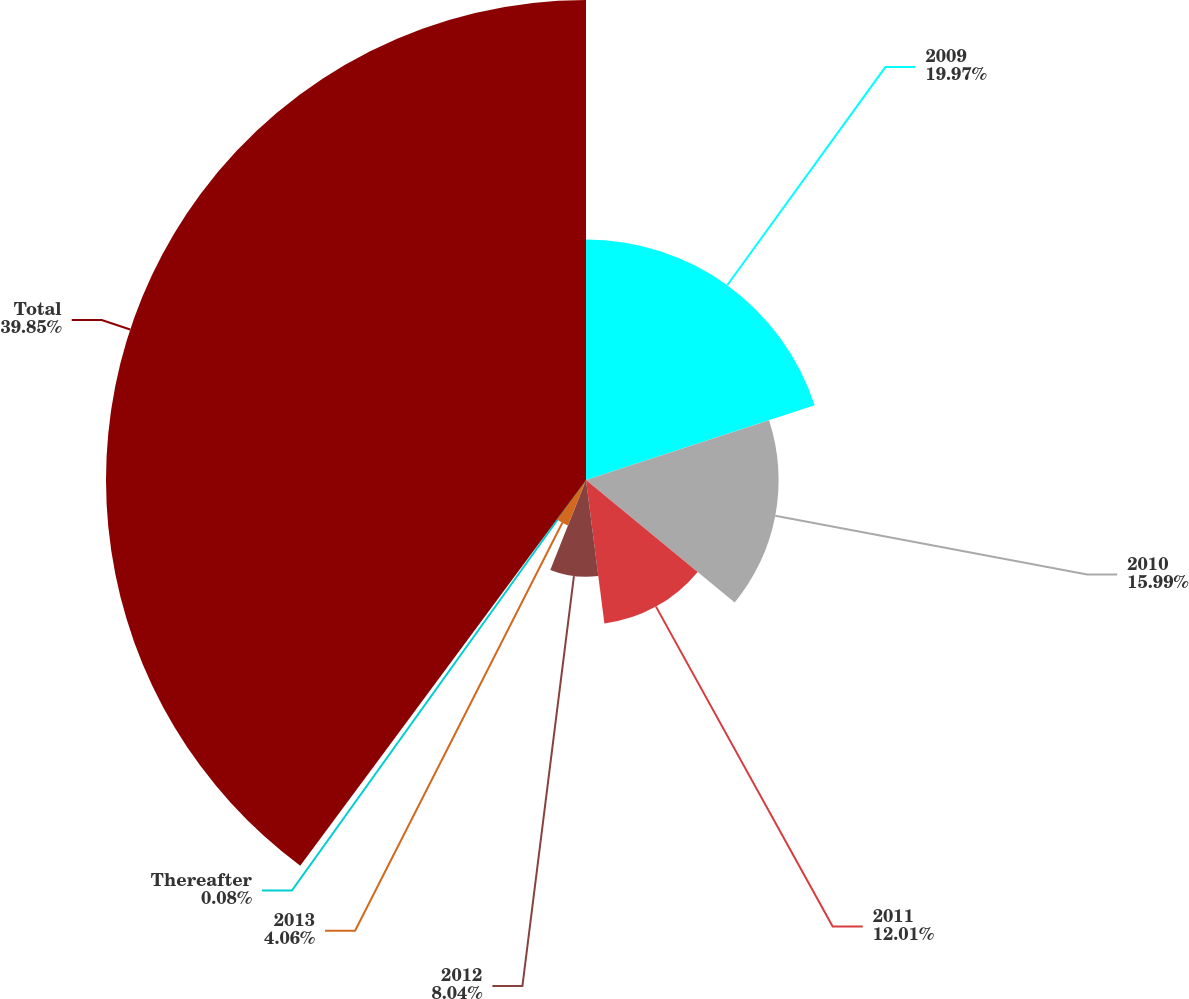<chart> <loc_0><loc_0><loc_500><loc_500><pie_chart><fcel>2009<fcel>2010<fcel>2011<fcel>2012<fcel>2013<fcel>Thereafter<fcel>Total<nl><fcel>19.97%<fcel>15.99%<fcel>12.01%<fcel>8.04%<fcel>4.06%<fcel>0.08%<fcel>39.85%<nl></chart> 